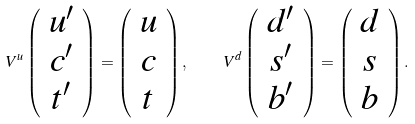Convert formula to latex. <formula><loc_0><loc_0><loc_500><loc_500>V ^ { u } \left ( \begin{array} { c } u ^ { \prime } \\ c ^ { \prime } \\ t ^ { \prime } \end{array} \right ) = \left ( \begin{array} { c } u \\ c \\ t \end{array} \right ) , \quad V ^ { d } \left ( \begin{array} { c } d ^ { \prime } \\ s ^ { \prime } \\ b ^ { \prime } \end{array} \right ) = \left ( \begin{array} { c } d \\ s \\ b \end{array} \right ) .</formula> 